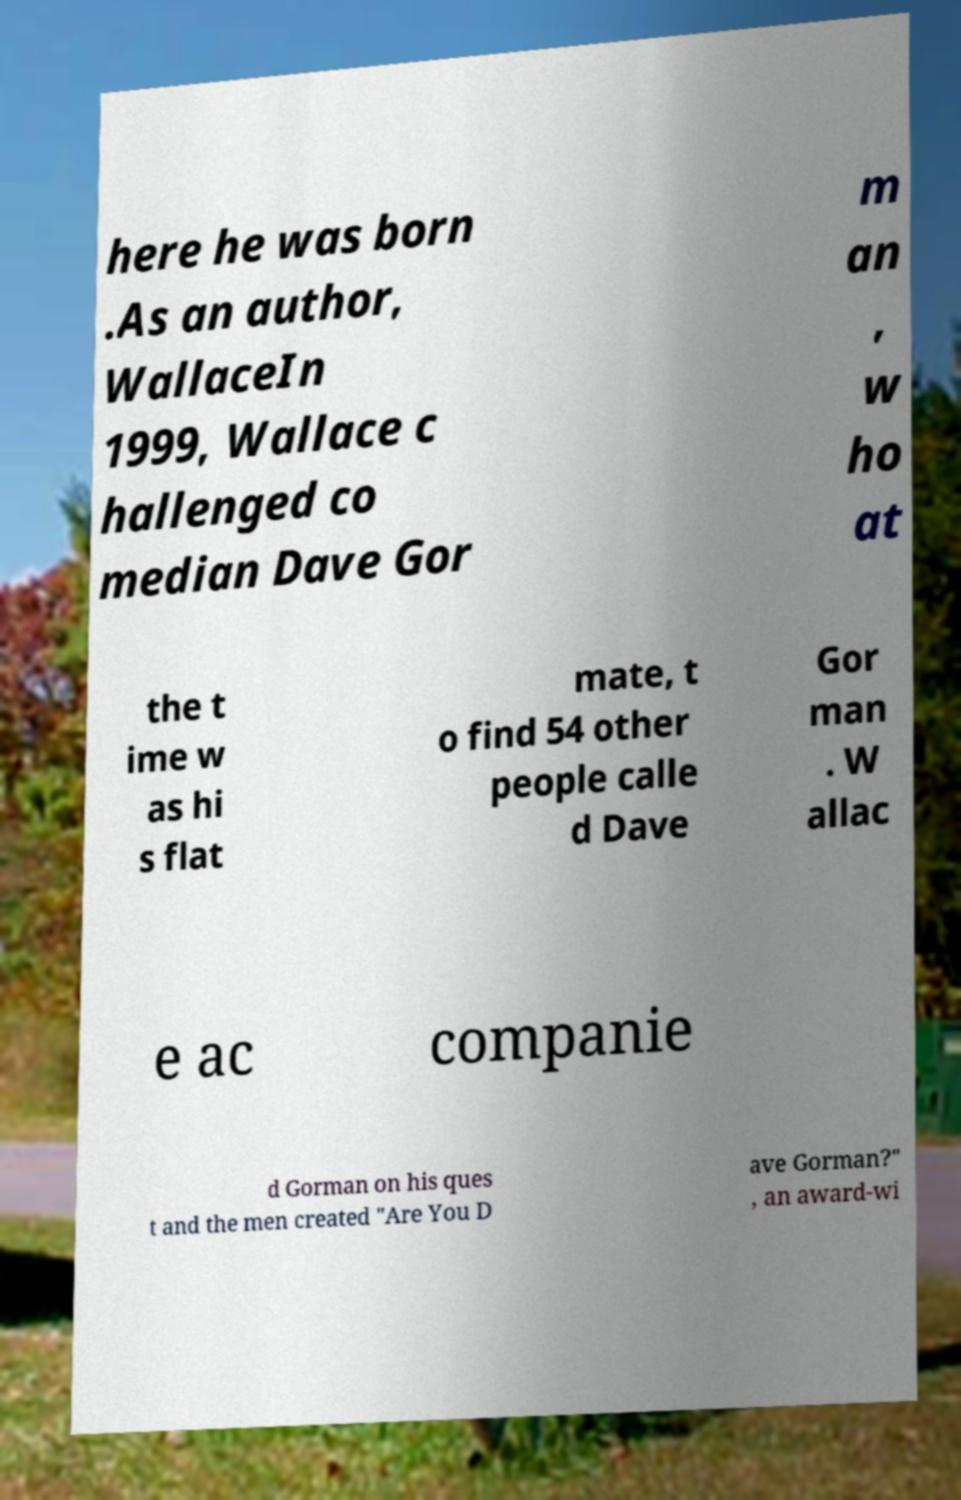Could you assist in decoding the text presented in this image and type it out clearly? here he was born .As an author, WallaceIn 1999, Wallace c hallenged co median Dave Gor m an , w ho at the t ime w as hi s flat mate, t o find 54 other people calle d Dave Gor man . W allac e ac companie d Gorman on his ques t and the men created "Are You D ave Gorman?" , an award-wi 